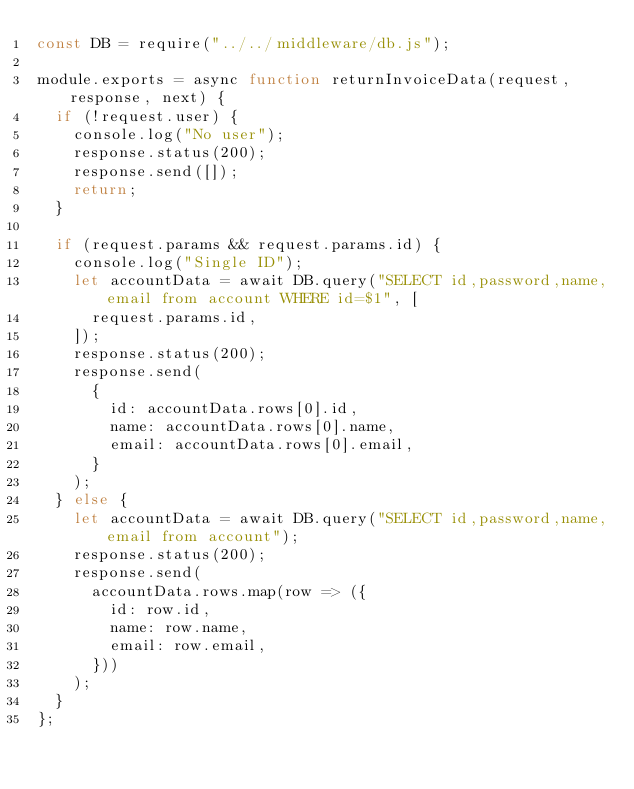<code> <loc_0><loc_0><loc_500><loc_500><_JavaScript_>const DB = require("../../middleware/db.js");

module.exports = async function returnInvoiceData(request, response, next) {
  if (!request.user) {
    console.log("No user");
    response.status(200);
    response.send([]);
    return;
  }

  if (request.params && request.params.id) {
    console.log("Single ID");
    let accountData = await DB.query("SELECT id,password,name,email from account WHERE id=$1", [
      request.params.id,
    ]);
    response.status(200);
    response.send(
      {
        id: accountData.rows[0].id,
        name: accountData.rows[0].name,
        email: accountData.rows[0].email,
      }
    );
  } else {
    let accountData = await DB.query("SELECT id,password,name,email from account");
    response.status(200);
    response.send(
      accountData.rows.map(row => ({
        id: row.id,
        name: row.name,
        email: row.email,
      }))
    );
  }
};
</code> 